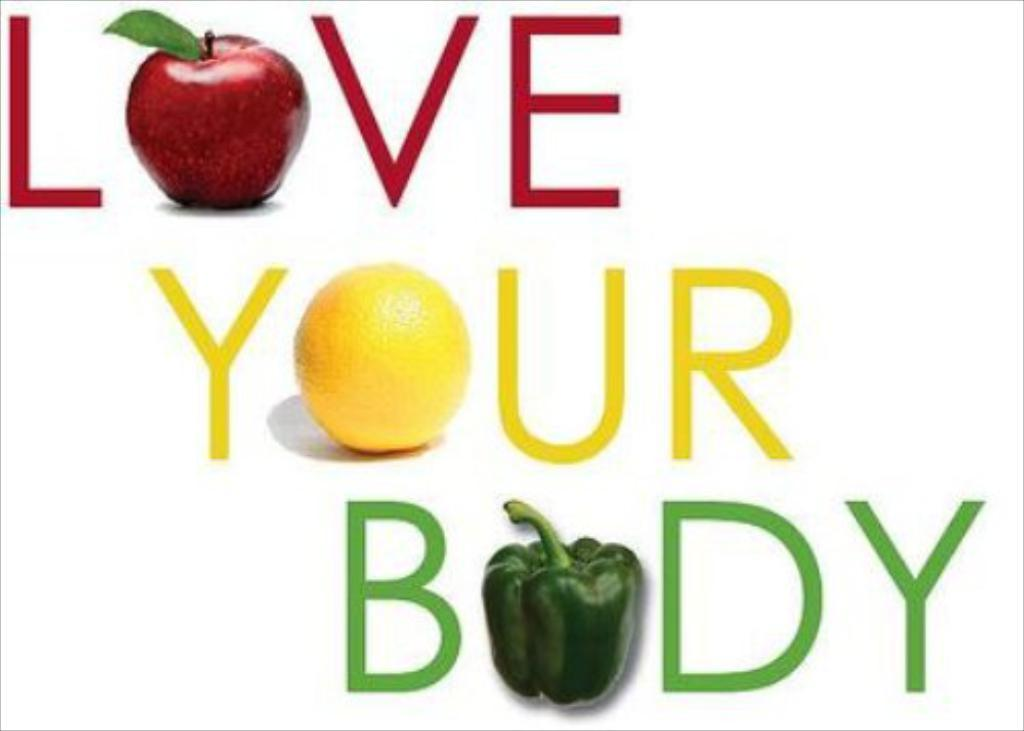What can be seen in the image besides text? There are images in the image. Can you describe the text in the image? Unfortunately, there is not enough information provided to describe the text in the image. Where is the rake placed in the image? There is no rake present in the image. What type of crack is visible on the shelf in the image? There is no shelf or crack present in the image. 